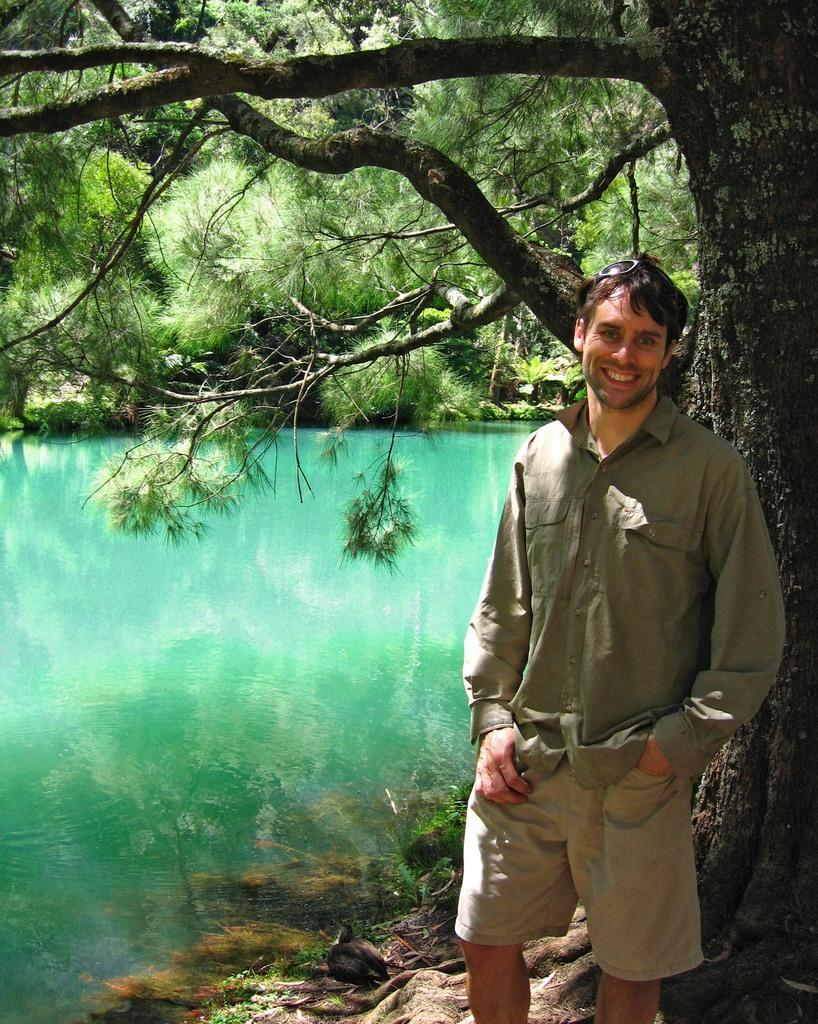Who is present in the image? There is a man standing in the image. What is the man's position in relation to the ground? The man is standing on the ground. What natural feature can be seen in the image? There is a lake visible in the image. What type of vegetation is present in the image? There are trees in the image. Is the girl holding a balloon in the image? There is no girl or balloon present in the image. What territory is being claimed by the man in the image? The image does not depict any territorial claims or disputes; it simply shows a man standing near a lake and trees. 